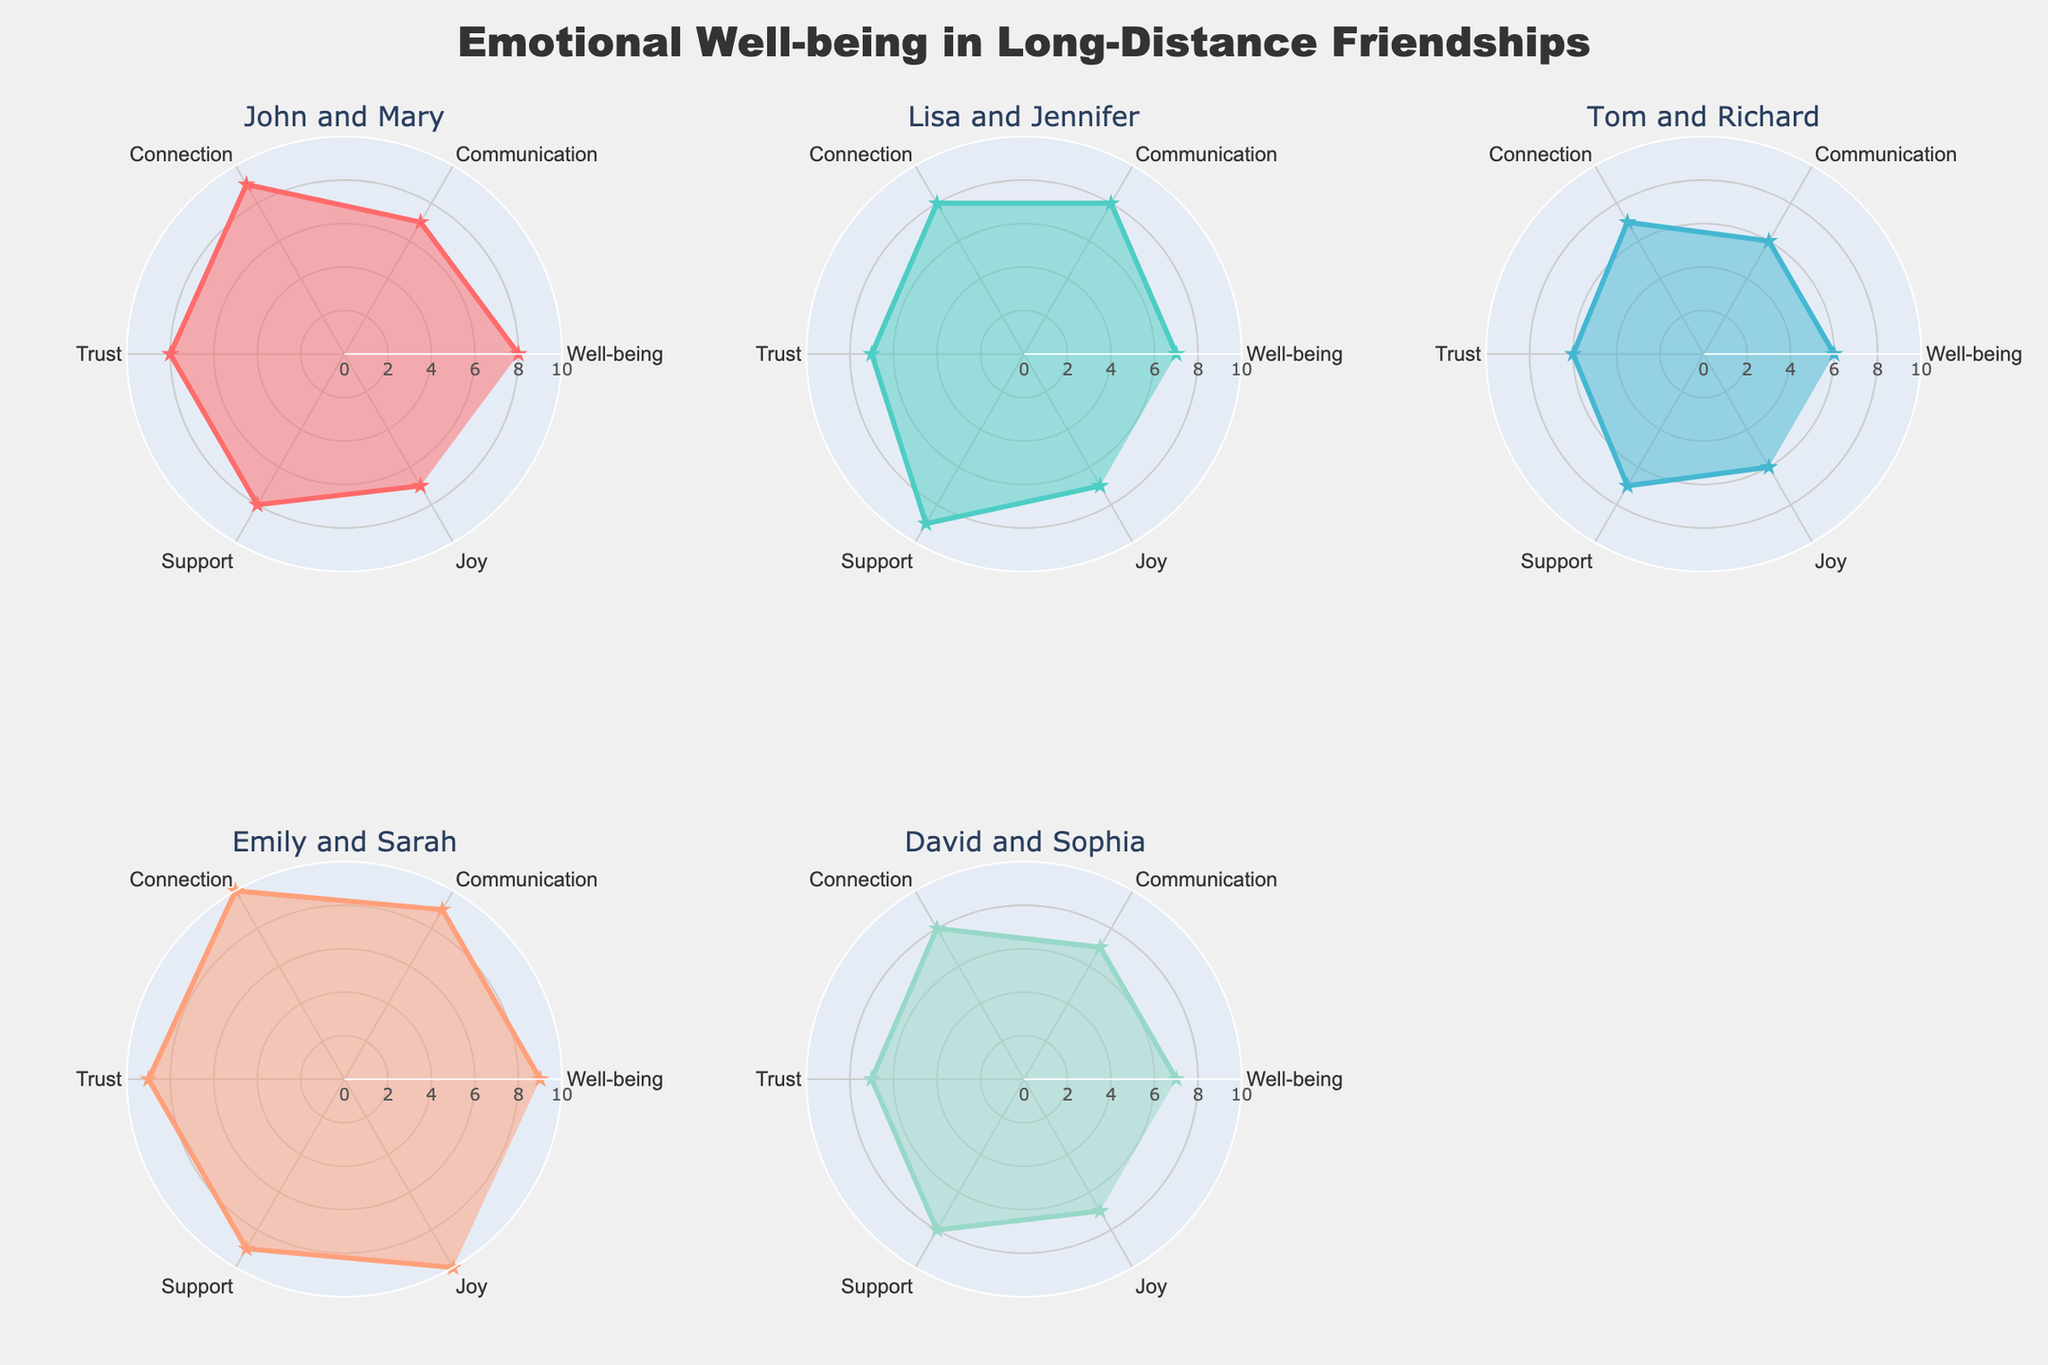What is the title of the figure? The title is mentioned at the top center of the figure.
Answer: Emotional Well-being in Long-Distance Friendships Which friendship has the highest score in the 'Joy' category? By comparing the values for the 'Joy' category in each subplot, Emily and Sarah have the highest score of 10.
Answer: Emily and Sarah What is the total well-being score of 'John and Mary'? Sum the values of all categories for 'John and Mary' which are 8, 7, 9, 8, 8, and 7. (8 + 7 + 9 + 8 + 8 + 7)
Answer: 47 Which friendship shows the greatest consistency in scores across all categories? By visually comparing the consistency of scores across the categories, Emily and Sarah's scores are uniformly high (9s and 10s).
Answer: Emily and Sarah Who has a higher support score, John and Mary or Lisa and Jennifer? Compare the 'Support' score of both friendships, John and Mary have a score of 8 while Lisa and Jennifer have a score of 9.
Answer: Lisa and Jennifer What is the average communication score for all friendships shown in the figure? Sum all the communication scores: 7 + 8 + 6 + 9 + 7 = 37. Divide by the number of friendships, so 37 / 5.
Answer: 7.4 Which friendship has the lowest trust score? By visually inspecting the trust scores, Tom and Richard have the lowest score of 6.
Answer: Tom and Richard What is the difference in connection scores between Tom and Richard and Emily and Sarah? Subtract the connection score for Tom and Richard (7) from the connection score for Emily and Sarah (10).
Answer: 3 How many categories does the radar chart measure for each friendship? Count the number of categories listed (Well-being, Communication, Connection, Trust, Support, Joy).
Answer: 6 Which friendship's scores form the most symmetrical shape in the radar chart? By examining the symmetry of the plotted shapes, 'Emily and Sarah' form the most symmetrical shape with consistently high scores.
Answer: Emily and Sarah 